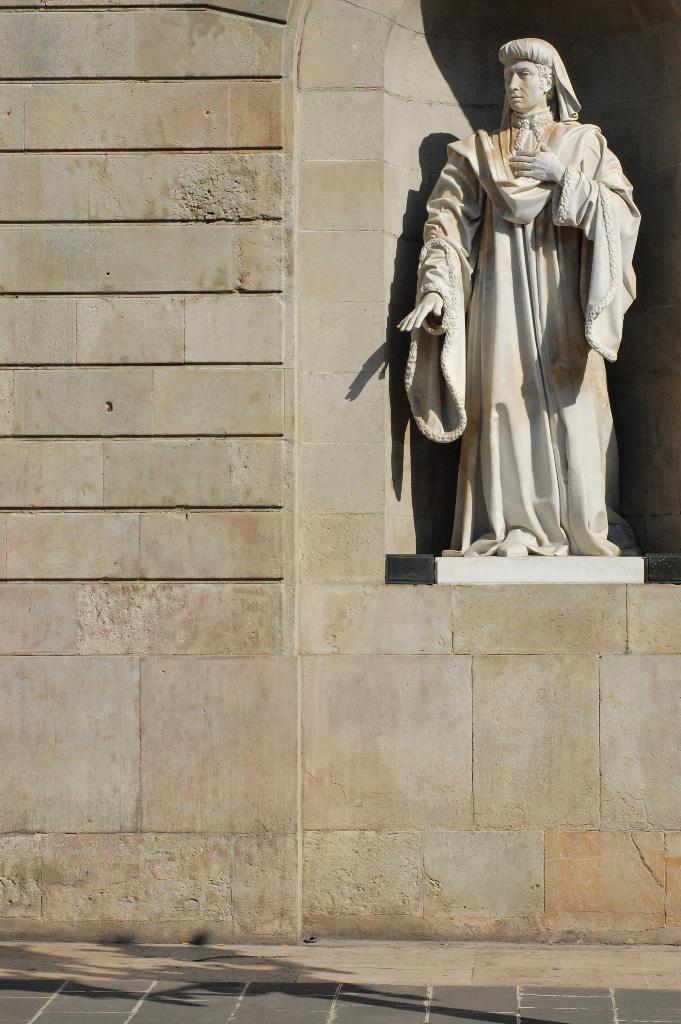In one or two sentences, can you explain what this image depicts? There is a white color statue on the wall of a building. Beside this building, there is a shadow of an object on the footpath. 